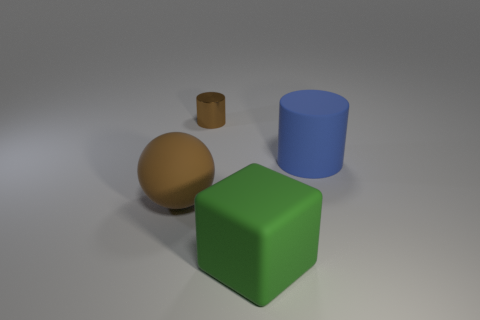Subtract all blue cylinders. How many cylinders are left? 1 Add 3 small red things. How many objects exist? 7 Subtract all blocks. How many objects are left? 3 Subtract all gray rubber blocks. Subtract all spheres. How many objects are left? 3 Add 2 matte balls. How many matte balls are left? 3 Add 3 green things. How many green things exist? 4 Subtract 0 brown cubes. How many objects are left? 4 Subtract all gray cylinders. Subtract all yellow spheres. How many cylinders are left? 2 